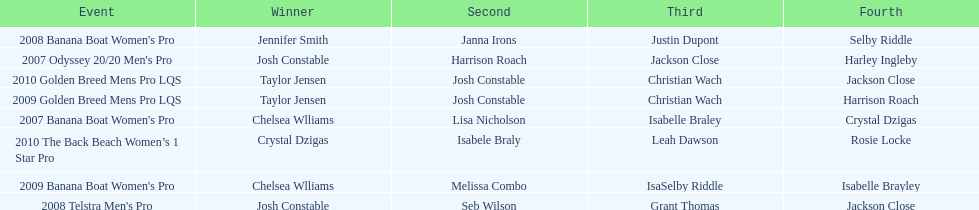Who was next to finish after josh constable in the 2008 telstra men's pro? Seb Wilson. 